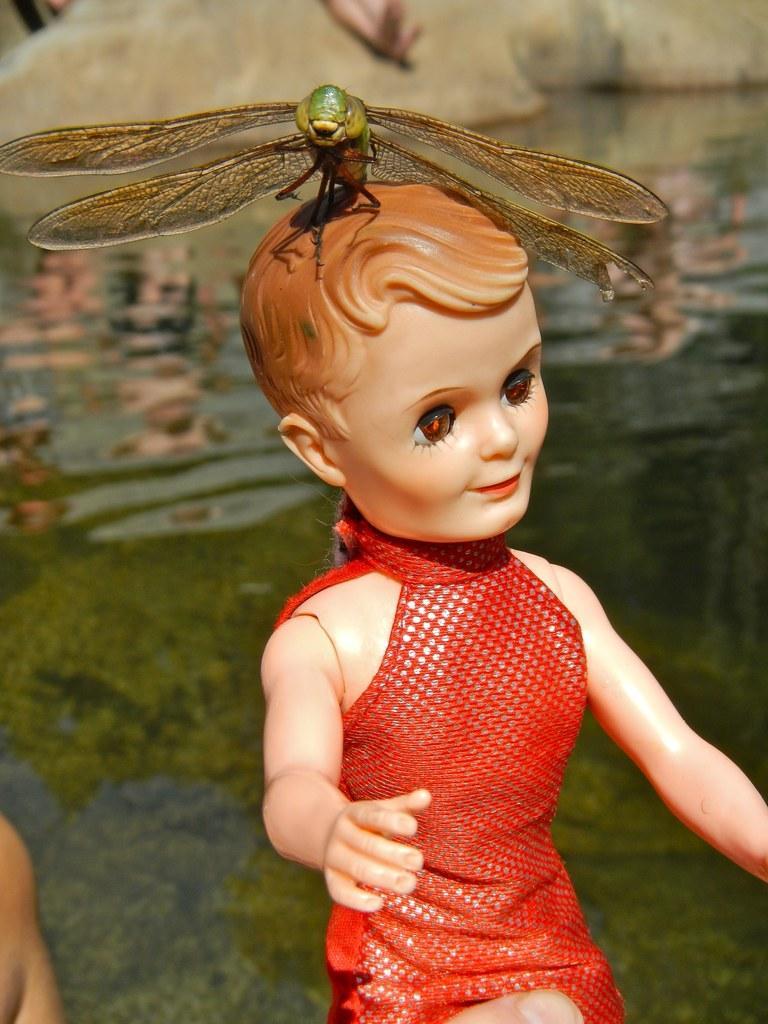Can you describe this image briefly? In the center of the image we can see one doll wearing a red dress. On the doll, we can see one dragonfly. And we can see one finger on the doll. In the background there is a wall, water and a few other objects. 